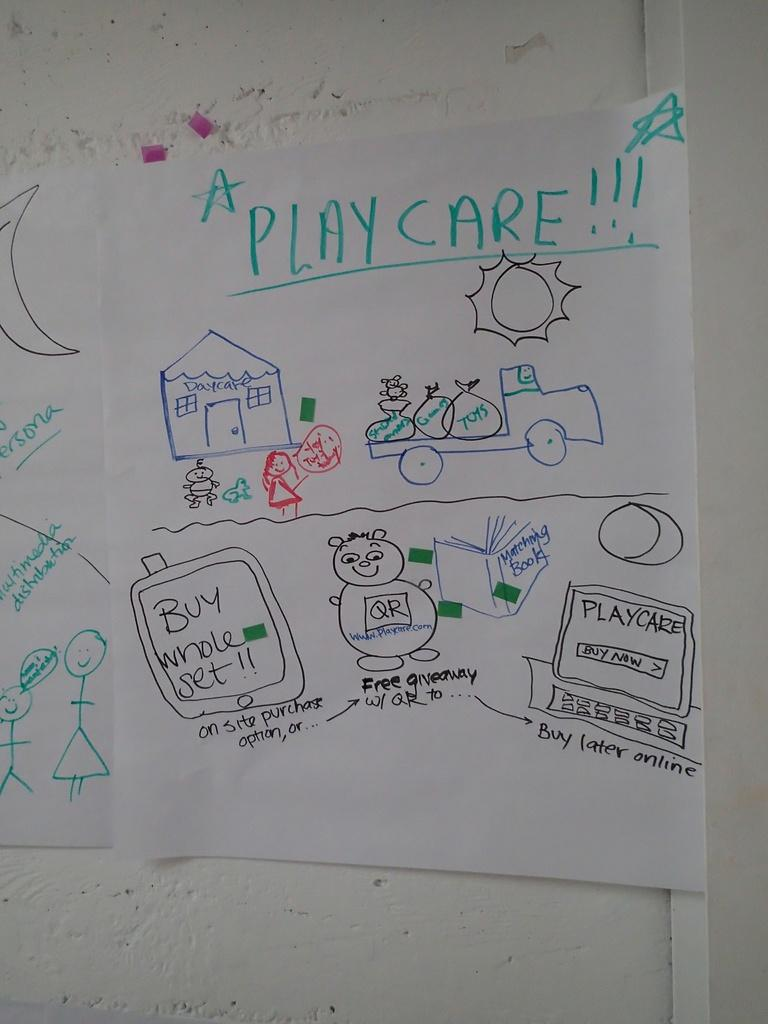<image>
Present a compact description of the photo's key features. Drawing of a family and the word "Playcare" on top. 